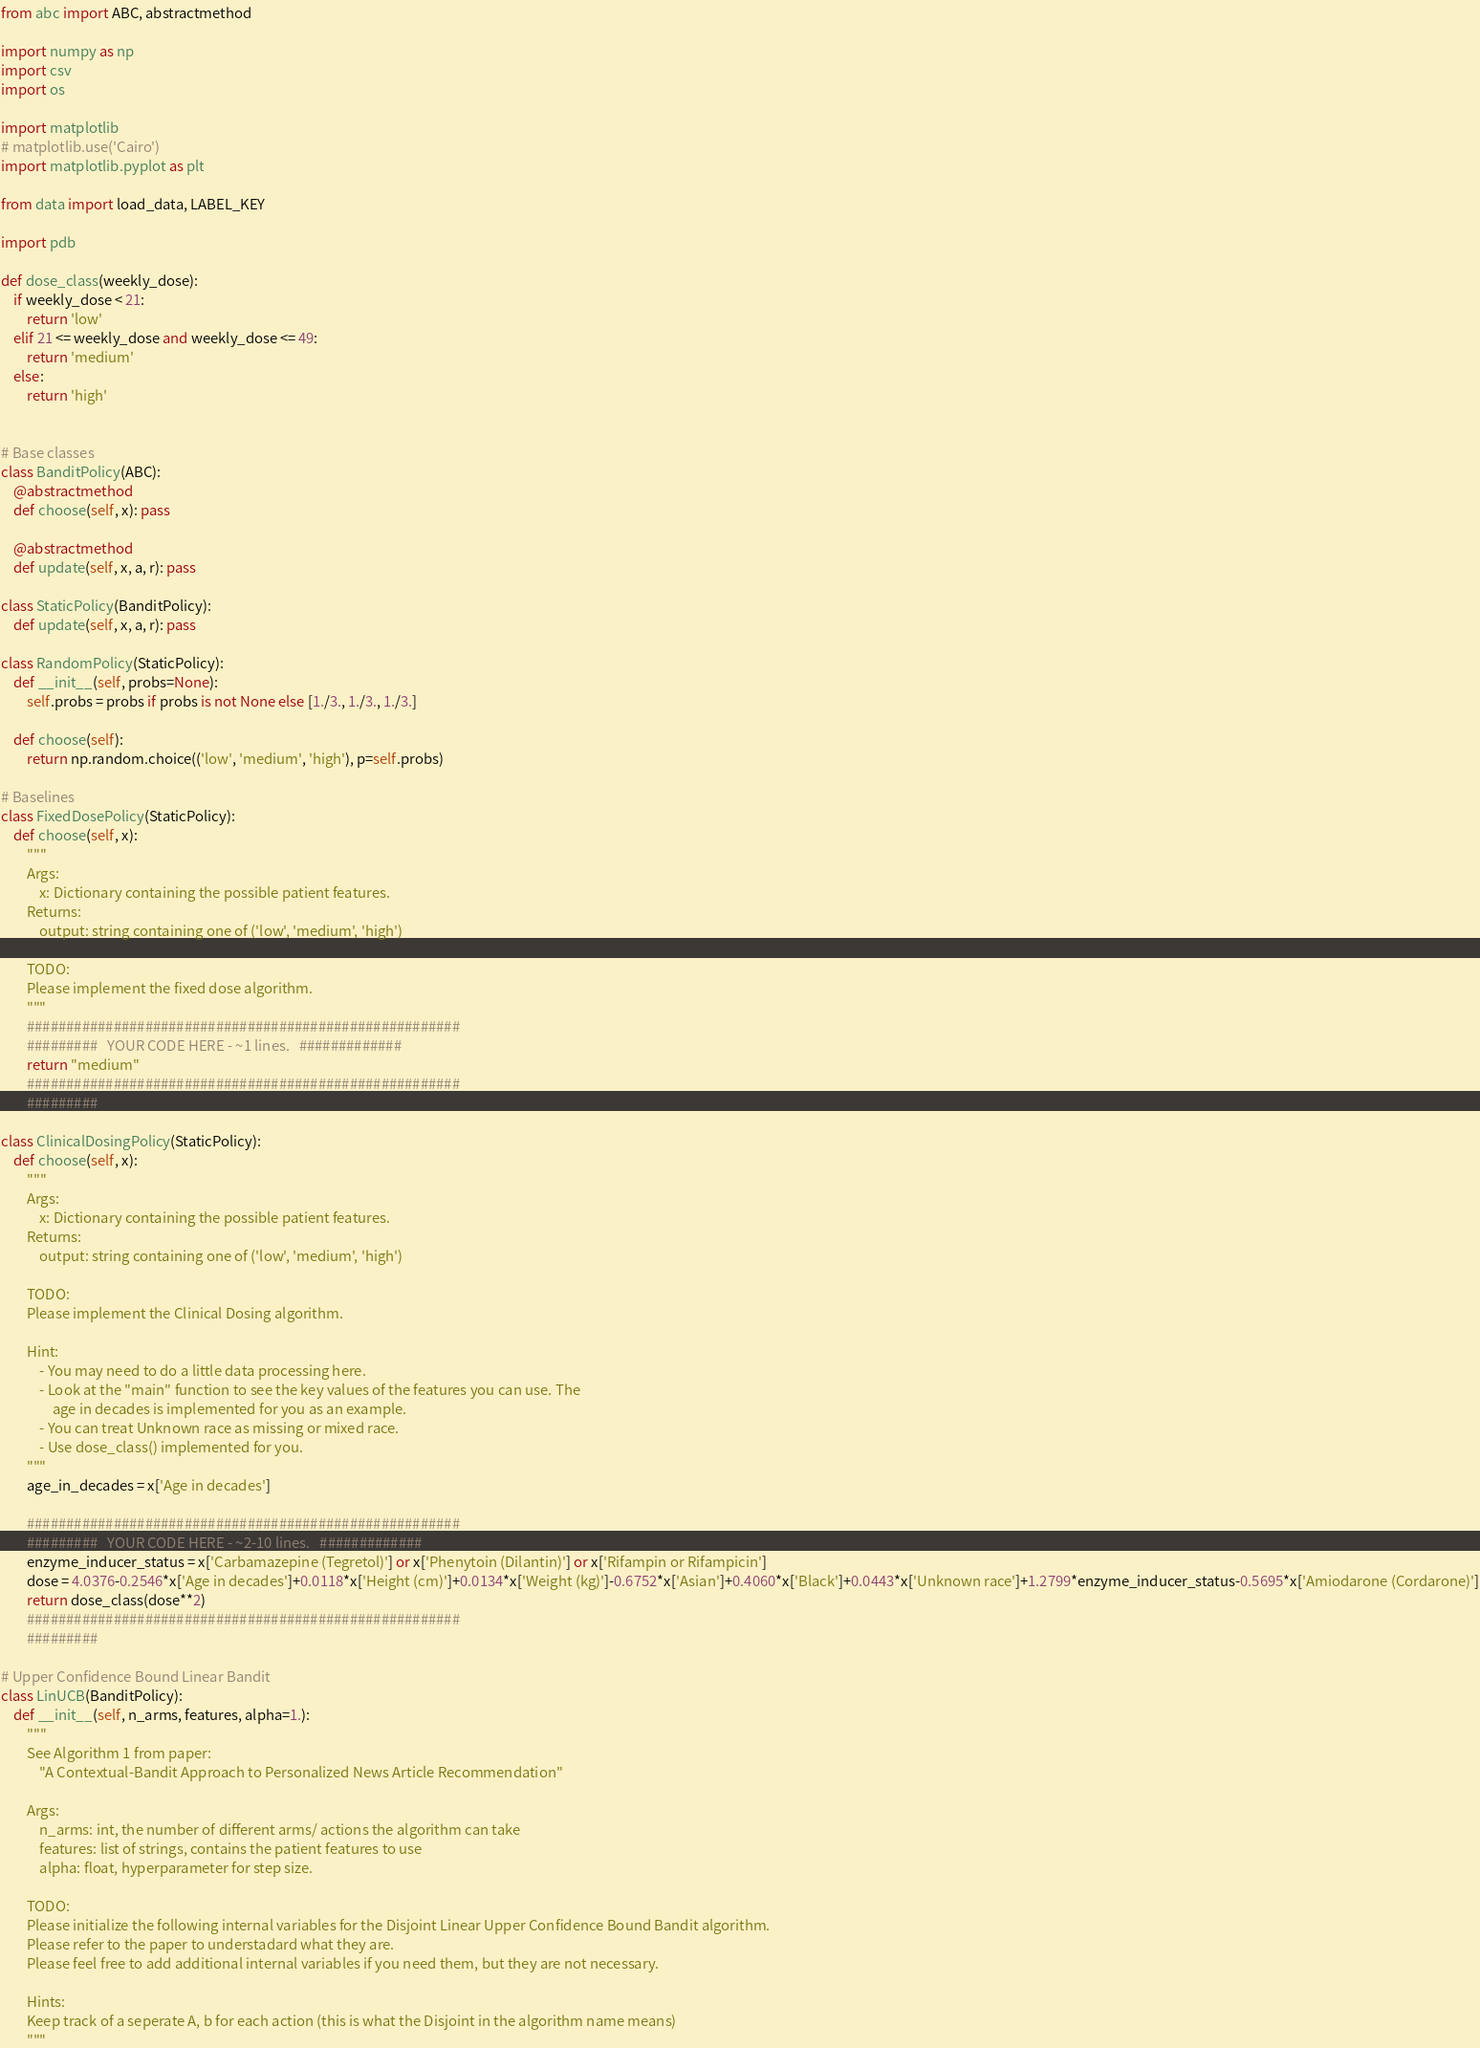Convert code to text. <code><loc_0><loc_0><loc_500><loc_500><_Python_>from abc import ABC, abstractmethod

import numpy as np
import csv
import os

import matplotlib
# matplotlib.use('Cairo')
import matplotlib.pyplot as plt

from data import load_data, LABEL_KEY

import pdb

def dose_class(weekly_dose):
	if weekly_dose < 21:
		return 'low'
	elif 21 <= weekly_dose and weekly_dose <= 49:
		return 'medium'
	else:
		return 'high'


# Base classes
class BanditPolicy(ABC):
	@abstractmethod
	def choose(self, x): pass

	@abstractmethod
	def update(self, x, a, r): pass

class StaticPolicy(BanditPolicy):
	def update(self, x, a, r): pass

class RandomPolicy(StaticPolicy):
	def __init__(self, probs=None):
		self.probs = probs if probs is not None else [1./3., 1./3., 1./3.]

	def choose(self):
		return np.random.choice(('low', 'medium', 'high'), p=self.probs)

# Baselines
class FixedDosePolicy(StaticPolicy):
	def choose(self, x):
		"""
		Args:
			x: Dictionary containing the possible patient features. 
		Returns:
			output: string containing one of ('low', 'medium', 'high')

		TODO:
		Please implement the fixed dose algorithm.
		"""
		#######################################################
		#########   YOUR CODE HERE - ~1 lines.   #############
		return "medium"
		#######################################################
		######### 

class ClinicalDosingPolicy(StaticPolicy):
	def choose(self, x):
		"""
		Args:
			x: Dictionary containing the possible patient features. 
		Returns:
			output: string containing one of ('low', 'medium', 'high')

		TODO:
		Please implement the Clinical Dosing algorithm.

		Hint:
			- You may need to do a little data processing here. 
			- Look at the "main" function to see the key values of the features you can use. The
				age in decades is implemented for you as an example.
			- You can treat Unknown race as missing or mixed race.
			- Use dose_class() implemented for you. 
		"""
		age_in_decades = x['Age in decades']

		#######################################################
		#########   YOUR CODE HERE - ~2-10 lines.   #############
		enzyme_inducer_status = x['Carbamazepine (Tegretol)'] or x['Phenytoin (Dilantin)'] or x['Rifampin or Rifampicin']
		dose = 4.0376-0.2546*x['Age in decades']+0.0118*x['Height (cm)']+0.0134*x['Weight (kg)']-0.6752*x['Asian']+0.4060*x['Black']+0.0443*x['Unknown race']+1.2799*enzyme_inducer_status-0.5695*x['Amiodarone (Cordarone)']
		return dose_class(dose**2)
		#######################################################
		######### 

# Upper Confidence Bound Linear Bandit
class LinUCB(BanditPolicy):
	def __init__(self, n_arms, features, alpha=1.):
		"""
		See Algorithm 1 from paper:
			"A Contextual-Bandit Approach to Personalized News Article Recommendation" 

		Args:
			n_arms: int, the number of different arms/ actions the algorithm can take 
			features: list of strings, contains the patient features to use 
			alpha: float, hyperparameter for step size. 
		
		TODO:
		Please initialize the following internal variables for the Disjoint Linear Upper Confidence Bound Bandit algorithm. 
		Please refer to the paper to understadard what they are. 
		Please feel free to add additional internal variables if you need them, but they are not necessary. 

		Hints:
		Keep track of a seperate A, b for each action (this is what the Disjoint in the algorithm name means)
		"""</code> 